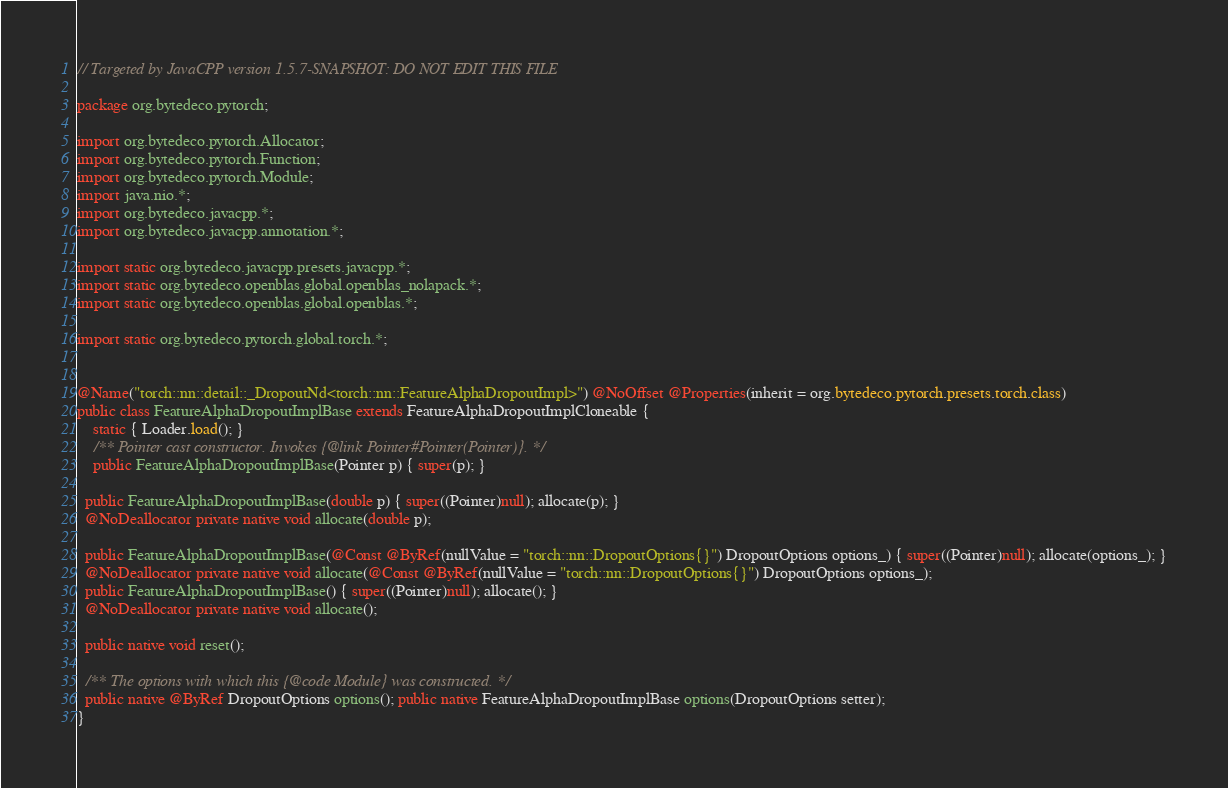<code> <loc_0><loc_0><loc_500><loc_500><_Java_>// Targeted by JavaCPP version 1.5.7-SNAPSHOT: DO NOT EDIT THIS FILE

package org.bytedeco.pytorch;

import org.bytedeco.pytorch.Allocator;
import org.bytedeco.pytorch.Function;
import org.bytedeco.pytorch.Module;
import java.nio.*;
import org.bytedeco.javacpp.*;
import org.bytedeco.javacpp.annotation.*;

import static org.bytedeco.javacpp.presets.javacpp.*;
import static org.bytedeco.openblas.global.openblas_nolapack.*;
import static org.bytedeco.openblas.global.openblas.*;

import static org.bytedeco.pytorch.global.torch.*;


@Name("torch::nn::detail::_DropoutNd<torch::nn::FeatureAlphaDropoutImpl>") @NoOffset @Properties(inherit = org.bytedeco.pytorch.presets.torch.class)
public class FeatureAlphaDropoutImplBase extends FeatureAlphaDropoutImplCloneable {
    static { Loader.load(); }
    /** Pointer cast constructor. Invokes {@link Pointer#Pointer(Pointer)}. */
    public FeatureAlphaDropoutImplBase(Pointer p) { super(p); }

  public FeatureAlphaDropoutImplBase(double p) { super((Pointer)null); allocate(p); }
  @NoDeallocator private native void allocate(double p);

  public FeatureAlphaDropoutImplBase(@Const @ByRef(nullValue = "torch::nn::DropoutOptions{}") DropoutOptions options_) { super((Pointer)null); allocate(options_); }
  @NoDeallocator private native void allocate(@Const @ByRef(nullValue = "torch::nn::DropoutOptions{}") DropoutOptions options_);
  public FeatureAlphaDropoutImplBase() { super((Pointer)null); allocate(); }
  @NoDeallocator private native void allocate();

  public native void reset();

  /** The options with which this {@code Module} was constructed. */
  public native @ByRef DropoutOptions options(); public native FeatureAlphaDropoutImplBase options(DropoutOptions setter);
}
</code> 